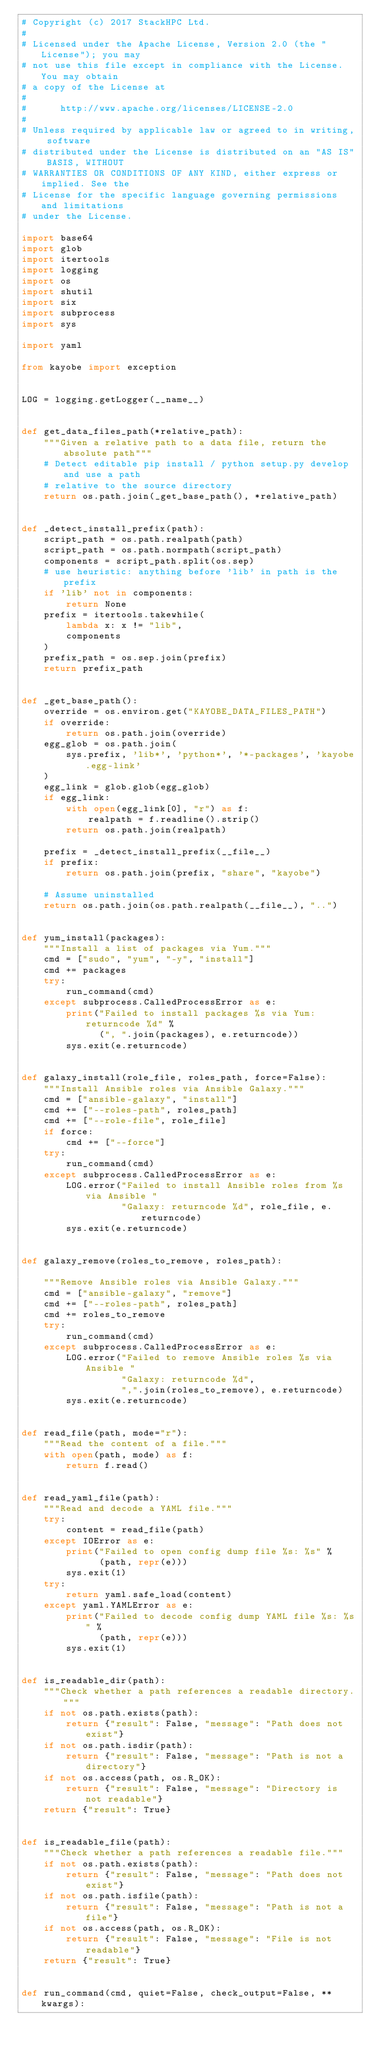Convert code to text. <code><loc_0><loc_0><loc_500><loc_500><_Python_># Copyright (c) 2017 StackHPC Ltd.
#
# Licensed under the Apache License, Version 2.0 (the "License"); you may
# not use this file except in compliance with the License. You may obtain
# a copy of the License at
#
#      http://www.apache.org/licenses/LICENSE-2.0
#
# Unless required by applicable law or agreed to in writing, software
# distributed under the License is distributed on an "AS IS" BASIS, WITHOUT
# WARRANTIES OR CONDITIONS OF ANY KIND, either express or implied. See the
# License for the specific language governing permissions and limitations
# under the License.

import base64
import glob
import itertools
import logging
import os
import shutil
import six
import subprocess
import sys

import yaml

from kayobe import exception


LOG = logging.getLogger(__name__)


def get_data_files_path(*relative_path):
    """Given a relative path to a data file, return the absolute path"""
    # Detect editable pip install / python setup.py develop and use a path
    # relative to the source directory
    return os.path.join(_get_base_path(), *relative_path)


def _detect_install_prefix(path):
    script_path = os.path.realpath(path)
    script_path = os.path.normpath(script_path)
    components = script_path.split(os.sep)
    # use heuristic: anything before 'lib' in path is the prefix
    if 'lib' not in components:
        return None
    prefix = itertools.takewhile(
        lambda x: x != "lib",
        components
    )
    prefix_path = os.sep.join(prefix)
    return prefix_path


def _get_base_path():
    override = os.environ.get("KAYOBE_DATA_FILES_PATH")
    if override:
        return os.path.join(override)
    egg_glob = os.path.join(
        sys.prefix, 'lib*', 'python*', '*-packages', 'kayobe.egg-link'
    )
    egg_link = glob.glob(egg_glob)
    if egg_link:
        with open(egg_link[0], "r") as f:
            realpath = f.readline().strip()
        return os.path.join(realpath)

    prefix = _detect_install_prefix(__file__)
    if prefix:
        return os.path.join(prefix, "share", "kayobe")

    # Assume uninstalled
    return os.path.join(os.path.realpath(__file__), "..")


def yum_install(packages):
    """Install a list of packages via Yum."""
    cmd = ["sudo", "yum", "-y", "install"]
    cmd += packages
    try:
        run_command(cmd)
    except subprocess.CalledProcessError as e:
        print("Failed to install packages %s via Yum: returncode %d" %
              (", ".join(packages), e.returncode))
        sys.exit(e.returncode)


def galaxy_install(role_file, roles_path, force=False):
    """Install Ansible roles via Ansible Galaxy."""
    cmd = ["ansible-galaxy", "install"]
    cmd += ["--roles-path", roles_path]
    cmd += ["--role-file", role_file]
    if force:
        cmd += ["--force"]
    try:
        run_command(cmd)
    except subprocess.CalledProcessError as e:
        LOG.error("Failed to install Ansible roles from %s via Ansible "
                  "Galaxy: returncode %d", role_file, e.returncode)
        sys.exit(e.returncode)


def galaxy_remove(roles_to_remove, roles_path):

    """Remove Ansible roles via Ansible Galaxy."""
    cmd = ["ansible-galaxy", "remove"]
    cmd += ["--roles-path", roles_path]
    cmd += roles_to_remove
    try:
        run_command(cmd)
    except subprocess.CalledProcessError as e:
        LOG.error("Failed to remove Ansible roles %s via Ansible "
                  "Galaxy: returncode %d",
                  ",".join(roles_to_remove), e.returncode)
        sys.exit(e.returncode)


def read_file(path, mode="r"):
    """Read the content of a file."""
    with open(path, mode) as f:
        return f.read()


def read_yaml_file(path):
    """Read and decode a YAML file."""
    try:
        content = read_file(path)
    except IOError as e:
        print("Failed to open config dump file %s: %s" %
              (path, repr(e)))
        sys.exit(1)
    try:
        return yaml.safe_load(content)
    except yaml.YAMLError as e:
        print("Failed to decode config dump YAML file %s: %s" %
              (path, repr(e)))
        sys.exit(1)


def is_readable_dir(path):
    """Check whether a path references a readable directory."""
    if not os.path.exists(path):
        return {"result": False, "message": "Path does not exist"}
    if not os.path.isdir(path):
        return {"result": False, "message": "Path is not a directory"}
    if not os.access(path, os.R_OK):
        return {"result": False, "message": "Directory is not readable"}
    return {"result": True}


def is_readable_file(path):
    """Check whether a path references a readable file."""
    if not os.path.exists(path):
        return {"result": False, "message": "Path does not exist"}
    if not os.path.isfile(path):
        return {"result": False, "message": "Path is not a file"}
    if not os.access(path, os.R_OK):
        return {"result": False, "message": "File is not readable"}
    return {"result": True}


def run_command(cmd, quiet=False, check_output=False, **kwargs):</code> 